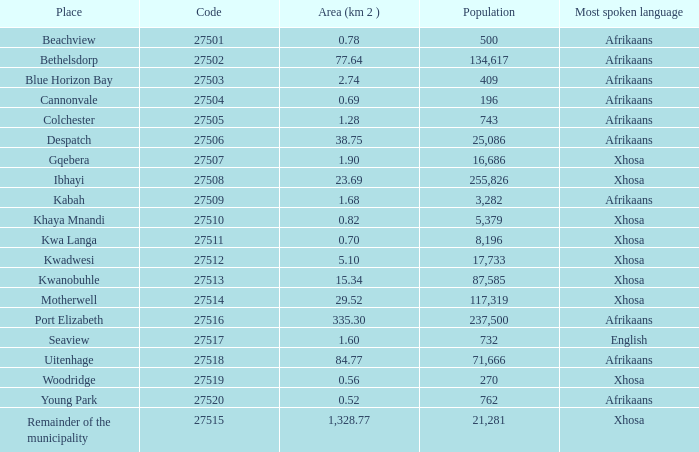What is the lowest area for cannonvale that speaks afrikaans? 0.69. 